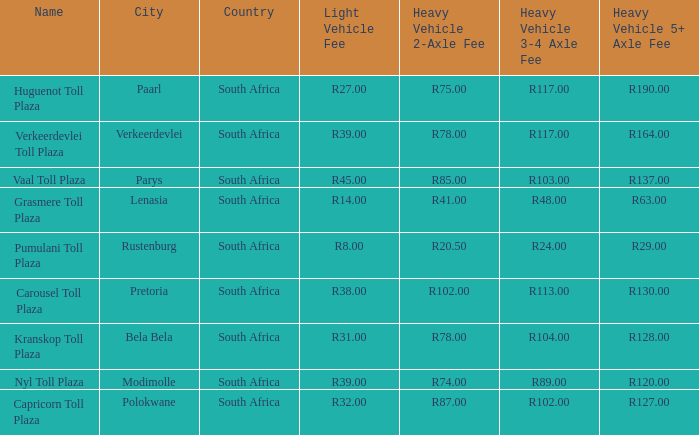What is the toll for light vehicles at the plaza where the toll for heavy vehicles with 2 axles is r87.00? R32.00. 